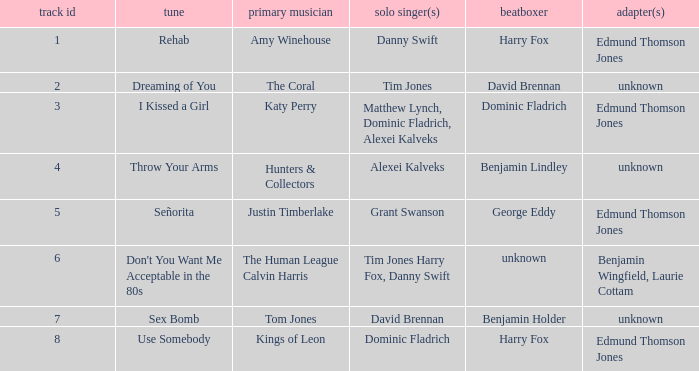Who is the artist where the vocal percussionist is Benjamin Holder? Tom Jones. 